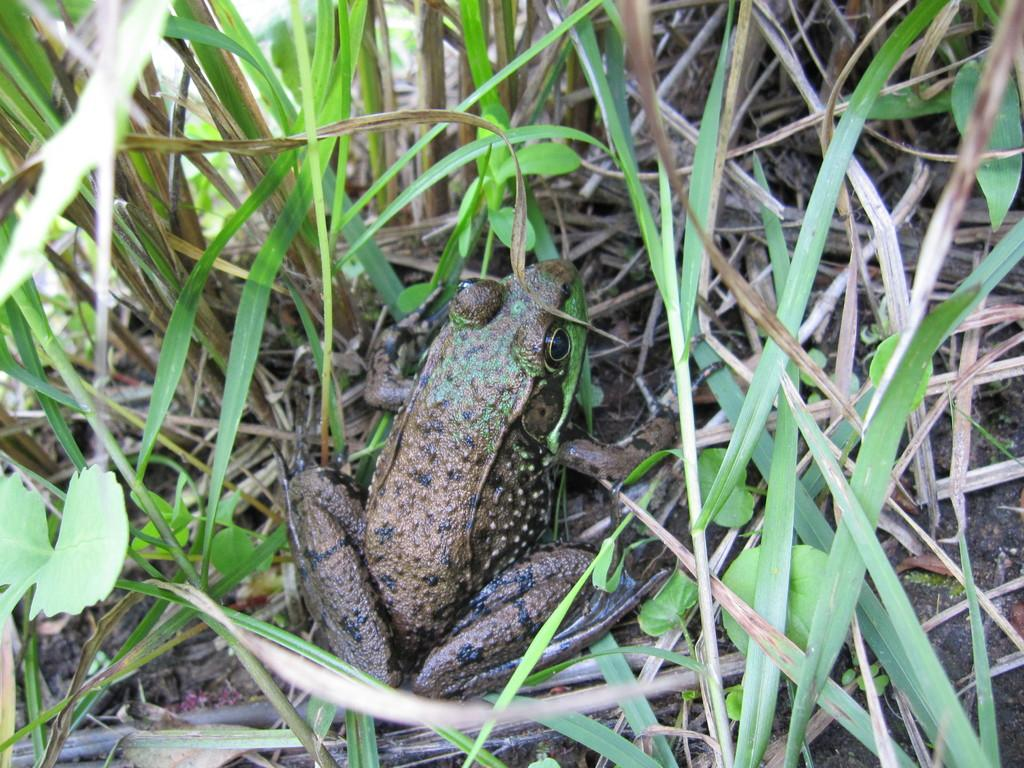What is the main subject in the center of the image? There is a frog in the center of the image. What type of vegetation can be seen in the image? There are plants in the image. What type of ground cover is present in the image? There is grass in the image. What type of surface is the frog and plants resting on? There is soil in the image. Where is the father sitting at the desk in the image? There is no father or desk present in the image; it features a frog, plants, grass, and soil. 